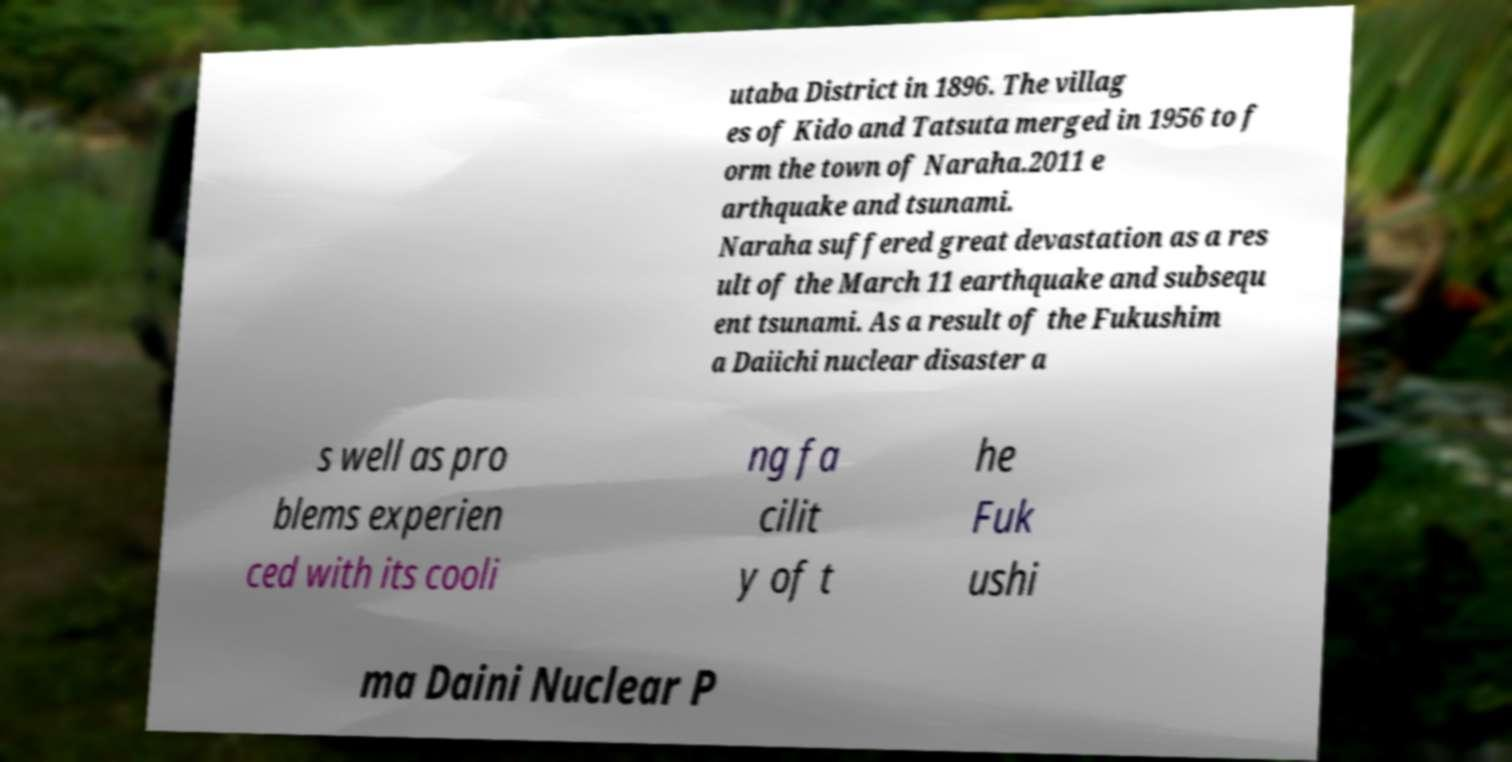Could you assist in decoding the text presented in this image and type it out clearly? utaba District in 1896. The villag es of Kido and Tatsuta merged in 1956 to f orm the town of Naraha.2011 e arthquake and tsunami. Naraha suffered great devastation as a res ult of the March 11 earthquake and subsequ ent tsunami. As a result of the Fukushim a Daiichi nuclear disaster a s well as pro blems experien ced with its cooli ng fa cilit y of t he Fuk ushi ma Daini Nuclear P 